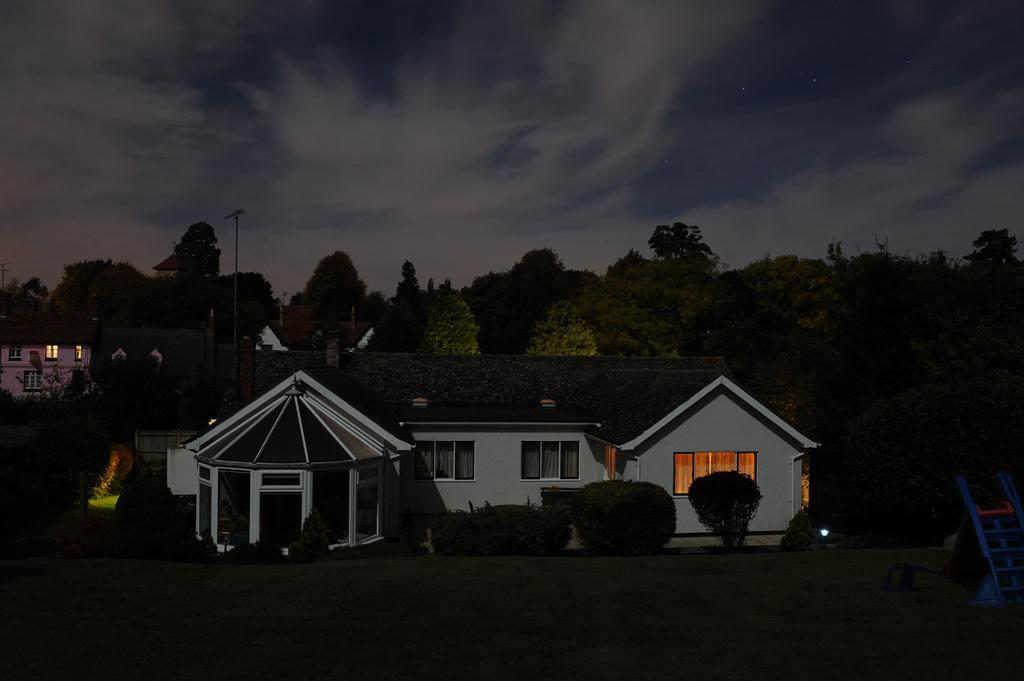Please provide a concise description of this image. In this image there are buildings and trees. Right side there is an object on the grassland. Left side there is a pole. Top of the image there is sky, having clouds. 